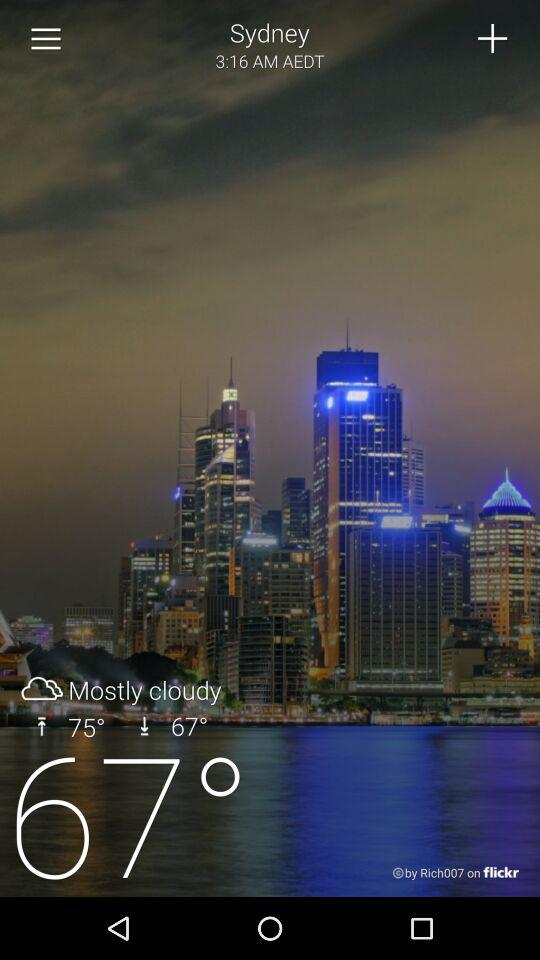How is the weather in Sydney? The weather is mostly cloudy. 